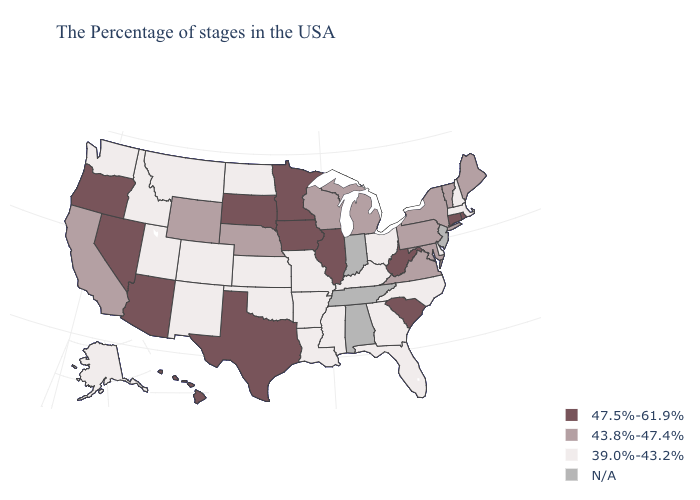Name the states that have a value in the range 39.0%-43.2%?
Concise answer only. Massachusetts, New Hampshire, Delaware, North Carolina, Ohio, Florida, Georgia, Kentucky, Mississippi, Louisiana, Missouri, Arkansas, Kansas, Oklahoma, North Dakota, Colorado, New Mexico, Utah, Montana, Idaho, Washington, Alaska. Does the map have missing data?
Give a very brief answer. Yes. What is the lowest value in the USA?
Short answer required. 39.0%-43.2%. What is the value of Ohio?
Quick response, please. 39.0%-43.2%. What is the value of Montana?
Give a very brief answer. 39.0%-43.2%. Which states have the highest value in the USA?
Quick response, please. Rhode Island, Connecticut, South Carolina, West Virginia, Illinois, Minnesota, Iowa, Texas, South Dakota, Arizona, Nevada, Oregon, Hawaii. Does New York have the highest value in the Northeast?
Be succinct. No. Does Texas have the highest value in the South?
Write a very short answer. Yes. Does North Dakota have the lowest value in the USA?
Concise answer only. Yes. Which states have the lowest value in the USA?
Be succinct. Massachusetts, New Hampshire, Delaware, North Carolina, Ohio, Florida, Georgia, Kentucky, Mississippi, Louisiana, Missouri, Arkansas, Kansas, Oklahoma, North Dakota, Colorado, New Mexico, Utah, Montana, Idaho, Washington, Alaska. What is the value of Wisconsin?
Write a very short answer. 43.8%-47.4%. Which states have the lowest value in the West?
Keep it brief. Colorado, New Mexico, Utah, Montana, Idaho, Washington, Alaska. What is the value of Vermont?
Quick response, please. 43.8%-47.4%. 